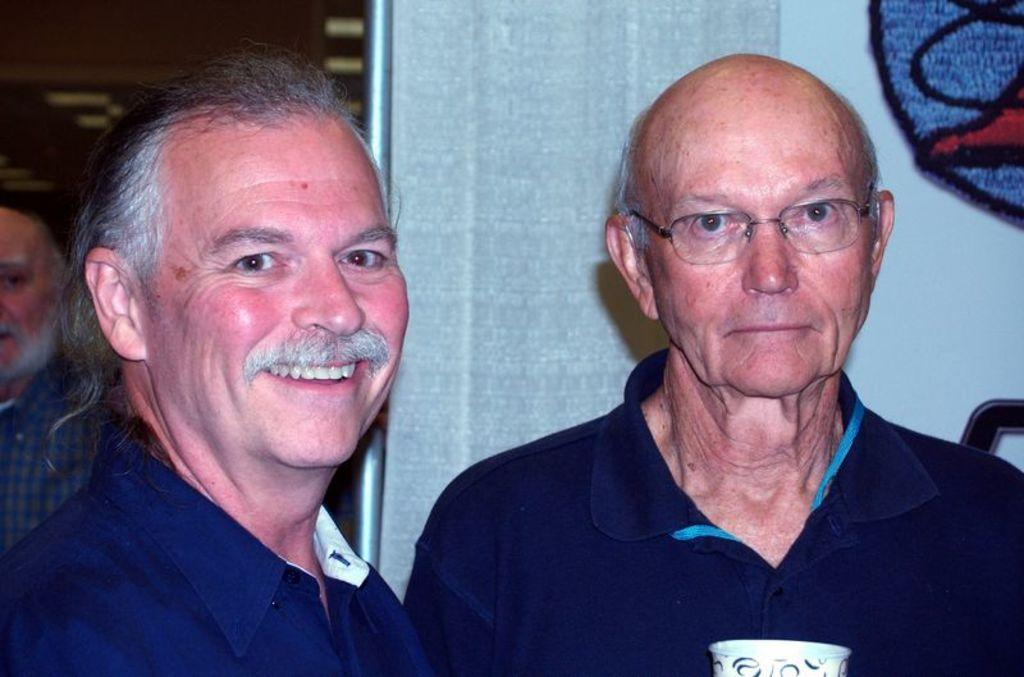How many persons are wearing blue dresses in the image? There are two persons wearing blue dresses in the image. Can you describe the position of the third person in the image? The third person is in the left corner of the image. What type of wax is being used by the father in the image? There is no father or wax present in the image. 